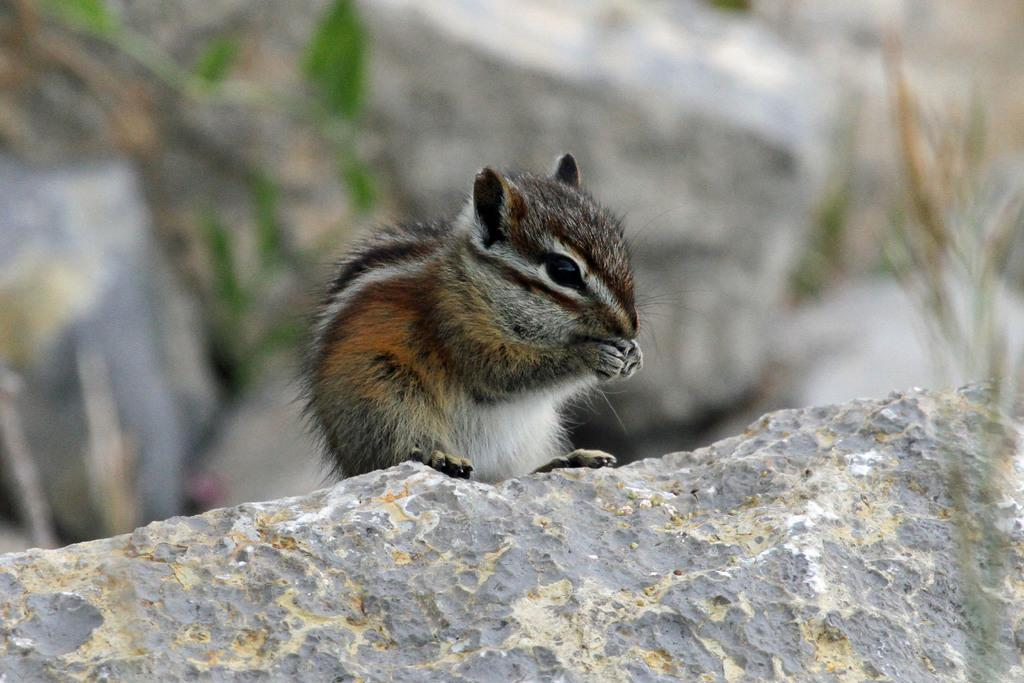What animal can be seen in the image? There is a squirrel in the image. Where is the squirrel located? The squirrel is sitting on a stone. Can you describe the background of the image? The background of the image is blurred. What type of soup is the squirrel holding in the image? There is no soup present in the image; it features a squirrel sitting on a stone. 